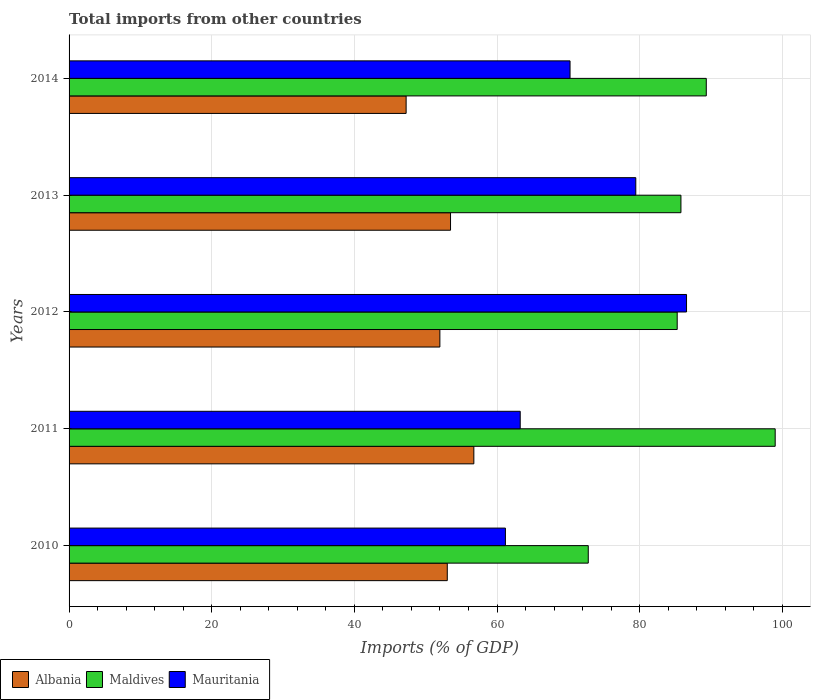Are the number of bars per tick equal to the number of legend labels?
Ensure brevity in your answer.  Yes. What is the label of the 1st group of bars from the top?
Your answer should be very brief. 2014. What is the total imports in Albania in 2012?
Your response must be concise. 51.99. Across all years, what is the maximum total imports in Mauritania?
Give a very brief answer. 86.57. Across all years, what is the minimum total imports in Albania?
Your answer should be compact. 47.25. In which year was the total imports in Albania maximum?
Your answer should be compact. 2011. In which year was the total imports in Mauritania minimum?
Your answer should be compact. 2010. What is the total total imports in Mauritania in the graph?
Your answer should be compact. 360.68. What is the difference between the total imports in Maldives in 2010 and that in 2011?
Your response must be concise. -26.21. What is the difference between the total imports in Maldives in 2014 and the total imports in Mauritania in 2012?
Offer a very short reply. 2.77. What is the average total imports in Albania per year?
Keep it short and to the point. 52.5. In the year 2012, what is the difference between the total imports in Albania and total imports in Maldives?
Provide a succinct answer. -33.27. What is the ratio of the total imports in Maldives in 2011 to that in 2013?
Your answer should be compact. 1.15. Is the total imports in Mauritania in 2010 less than that in 2014?
Your answer should be very brief. Yes. What is the difference between the highest and the second highest total imports in Mauritania?
Provide a short and direct response. 7.11. What is the difference between the highest and the lowest total imports in Albania?
Give a very brief answer. 9.49. Is the sum of the total imports in Maldives in 2010 and 2014 greater than the maximum total imports in Albania across all years?
Offer a terse response. Yes. What does the 3rd bar from the top in 2012 represents?
Keep it short and to the point. Albania. What does the 2nd bar from the bottom in 2010 represents?
Keep it short and to the point. Maldives. Does the graph contain any zero values?
Your answer should be very brief. No. Does the graph contain grids?
Provide a short and direct response. Yes. How many legend labels are there?
Your answer should be very brief. 3. What is the title of the graph?
Your answer should be compact. Total imports from other countries. Does "Egypt, Arab Rep." appear as one of the legend labels in the graph?
Offer a very short reply. No. What is the label or title of the X-axis?
Provide a succinct answer. Imports (% of GDP). What is the label or title of the Y-axis?
Offer a terse response. Years. What is the Imports (% of GDP) in Albania in 2010?
Provide a short and direct response. 53.02. What is the Imports (% of GDP) of Maldives in 2010?
Offer a very short reply. 72.79. What is the Imports (% of GDP) of Mauritania in 2010?
Provide a short and direct response. 61.18. What is the Imports (% of GDP) of Albania in 2011?
Your answer should be very brief. 56.75. What is the Imports (% of GDP) of Maldives in 2011?
Provide a short and direct response. 99. What is the Imports (% of GDP) in Mauritania in 2011?
Ensure brevity in your answer.  63.25. What is the Imports (% of GDP) of Albania in 2012?
Make the answer very short. 51.99. What is the Imports (% of GDP) in Maldives in 2012?
Your answer should be compact. 85.26. What is the Imports (% of GDP) in Mauritania in 2012?
Offer a very short reply. 86.57. What is the Imports (% of GDP) in Albania in 2013?
Your answer should be very brief. 53.48. What is the Imports (% of GDP) of Maldives in 2013?
Provide a succinct answer. 85.78. What is the Imports (% of GDP) in Mauritania in 2013?
Your response must be concise. 79.45. What is the Imports (% of GDP) in Albania in 2014?
Your answer should be compact. 47.25. What is the Imports (% of GDP) in Maldives in 2014?
Give a very brief answer. 89.34. What is the Imports (% of GDP) in Mauritania in 2014?
Keep it short and to the point. 70.24. Across all years, what is the maximum Imports (% of GDP) in Albania?
Give a very brief answer. 56.75. Across all years, what is the maximum Imports (% of GDP) of Maldives?
Provide a short and direct response. 99. Across all years, what is the maximum Imports (% of GDP) of Mauritania?
Your response must be concise. 86.57. Across all years, what is the minimum Imports (% of GDP) of Albania?
Ensure brevity in your answer.  47.25. Across all years, what is the minimum Imports (% of GDP) of Maldives?
Your response must be concise. 72.79. Across all years, what is the minimum Imports (% of GDP) of Mauritania?
Offer a very short reply. 61.18. What is the total Imports (% of GDP) of Albania in the graph?
Make the answer very short. 262.5. What is the total Imports (% of GDP) in Maldives in the graph?
Your answer should be compact. 432.17. What is the total Imports (% of GDP) of Mauritania in the graph?
Provide a succinct answer. 360.68. What is the difference between the Imports (% of GDP) in Albania in 2010 and that in 2011?
Provide a short and direct response. -3.72. What is the difference between the Imports (% of GDP) in Maldives in 2010 and that in 2011?
Make the answer very short. -26.21. What is the difference between the Imports (% of GDP) in Mauritania in 2010 and that in 2011?
Ensure brevity in your answer.  -2.08. What is the difference between the Imports (% of GDP) of Albania in 2010 and that in 2012?
Your response must be concise. 1.04. What is the difference between the Imports (% of GDP) in Maldives in 2010 and that in 2012?
Provide a succinct answer. -12.47. What is the difference between the Imports (% of GDP) of Mauritania in 2010 and that in 2012?
Keep it short and to the point. -25.39. What is the difference between the Imports (% of GDP) of Albania in 2010 and that in 2013?
Make the answer very short. -0.46. What is the difference between the Imports (% of GDP) of Maldives in 2010 and that in 2013?
Provide a short and direct response. -12.99. What is the difference between the Imports (% of GDP) of Mauritania in 2010 and that in 2013?
Give a very brief answer. -18.28. What is the difference between the Imports (% of GDP) in Albania in 2010 and that in 2014?
Offer a terse response. 5.77. What is the difference between the Imports (% of GDP) of Maldives in 2010 and that in 2014?
Your response must be concise. -16.54. What is the difference between the Imports (% of GDP) in Mauritania in 2010 and that in 2014?
Give a very brief answer. -9.06. What is the difference between the Imports (% of GDP) of Albania in 2011 and that in 2012?
Your response must be concise. 4.76. What is the difference between the Imports (% of GDP) of Maldives in 2011 and that in 2012?
Give a very brief answer. 13.74. What is the difference between the Imports (% of GDP) in Mauritania in 2011 and that in 2012?
Provide a short and direct response. -23.32. What is the difference between the Imports (% of GDP) of Albania in 2011 and that in 2013?
Your response must be concise. 3.27. What is the difference between the Imports (% of GDP) in Maldives in 2011 and that in 2013?
Offer a terse response. 13.21. What is the difference between the Imports (% of GDP) in Mauritania in 2011 and that in 2013?
Your response must be concise. -16.2. What is the difference between the Imports (% of GDP) in Albania in 2011 and that in 2014?
Offer a very short reply. 9.49. What is the difference between the Imports (% of GDP) of Maldives in 2011 and that in 2014?
Your answer should be very brief. 9.66. What is the difference between the Imports (% of GDP) of Mauritania in 2011 and that in 2014?
Your response must be concise. -6.98. What is the difference between the Imports (% of GDP) in Albania in 2012 and that in 2013?
Provide a succinct answer. -1.49. What is the difference between the Imports (% of GDP) in Maldives in 2012 and that in 2013?
Offer a very short reply. -0.52. What is the difference between the Imports (% of GDP) of Mauritania in 2012 and that in 2013?
Provide a short and direct response. 7.11. What is the difference between the Imports (% of GDP) in Albania in 2012 and that in 2014?
Your answer should be compact. 4.73. What is the difference between the Imports (% of GDP) of Maldives in 2012 and that in 2014?
Give a very brief answer. -4.08. What is the difference between the Imports (% of GDP) of Mauritania in 2012 and that in 2014?
Your answer should be compact. 16.33. What is the difference between the Imports (% of GDP) of Albania in 2013 and that in 2014?
Provide a succinct answer. 6.23. What is the difference between the Imports (% of GDP) of Maldives in 2013 and that in 2014?
Give a very brief answer. -3.55. What is the difference between the Imports (% of GDP) in Mauritania in 2013 and that in 2014?
Your response must be concise. 9.22. What is the difference between the Imports (% of GDP) in Albania in 2010 and the Imports (% of GDP) in Maldives in 2011?
Offer a terse response. -45.97. What is the difference between the Imports (% of GDP) in Albania in 2010 and the Imports (% of GDP) in Mauritania in 2011?
Keep it short and to the point. -10.23. What is the difference between the Imports (% of GDP) in Maldives in 2010 and the Imports (% of GDP) in Mauritania in 2011?
Give a very brief answer. 9.54. What is the difference between the Imports (% of GDP) in Albania in 2010 and the Imports (% of GDP) in Maldives in 2012?
Make the answer very short. -32.24. What is the difference between the Imports (% of GDP) of Albania in 2010 and the Imports (% of GDP) of Mauritania in 2012?
Ensure brevity in your answer.  -33.54. What is the difference between the Imports (% of GDP) in Maldives in 2010 and the Imports (% of GDP) in Mauritania in 2012?
Make the answer very short. -13.78. What is the difference between the Imports (% of GDP) of Albania in 2010 and the Imports (% of GDP) of Maldives in 2013?
Your answer should be very brief. -32.76. What is the difference between the Imports (% of GDP) in Albania in 2010 and the Imports (% of GDP) in Mauritania in 2013?
Your response must be concise. -26.43. What is the difference between the Imports (% of GDP) in Maldives in 2010 and the Imports (% of GDP) in Mauritania in 2013?
Provide a short and direct response. -6.66. What is the difference between the Imports (% of GDP) in Albania in 2010 and the Imports (% of GDP) in Maldives in 2014?
Give a very brief answer. -36.31. What is the difference between the Imports (% of GDP) of Albania in 2010 and the Imports (% of GDP) of Mauritania in 2014?
Your response must be concise. -17.21. What is the difference between the Imports (% of GDP) of Maldives in 2010 and the Imports (% of GDP) of Mauritania in 2014?
Give a very brief answer. 2.56. What is the difference between the Imports (% of GDP) in Albania in 2011 and the Imports (% of GDP) in Maldives in 2012?
Provide a succinct answer. -28.51. What is the difference between the Imports (% of GDP) in Albania in 2011 and the Imports (% of GDP) in Mauritania in 2012?
Ensure brevity in your answer.  -29.82. What is the difference between the Imports (% of GDP) of Maldives in 2011 and the Imports (% of GDP) of Mauritania in 2012?
Offer a terse response. 12.43. What is the difference between the Imports (% of GDP) in Albania in 2011 and the Imports (% of GDP) in Maldives in 2013?
Offer a very short reply. -29.04. What is the difference between the Imports (% of GDP) in Albania in 2011 and the Imports (% of GDP) in Mauritania in 2013?
Your response must be concise. -22.7. What is the difference between the Imports (% of GDP) of Maldives in 2011 and the Imports (% of GDP) of Mauritania in 2013?
Your response must be concise. 19.54. What is the difference between the Imports (% of GDP) of Albania in 2011 and the Imports (% of GDP) of Maldives in 2014?
Keep it short and to the point. -32.59. What is the difference between the Imports (% of GDP) of Albania in 2011 and the Imports (% of GDP) of Mauritania in 2014?
Make the answer very short. -13.49. What is the difference between the Imports (% of GDP) of Maldives in 2011 and the Imports (% of GDP) of Mauritania in 2014?
Provide a succinct answer. 28.76. What is the difference between the Imports (% of GDP) of Albania in 2012 and the Imports (% of GDP) of Maldives in 2013?
Your answer should be compact. -33.8. What is the difference between the Imports (% of GDP) of Albania in 2012 and the Imports (% of GDP) of Mauritania in 2013?
Offer a terse response. -27.47. What is the difference between the Imports (% of GDP) in Maldives in 2012 and the Imports (% of GDP) in Mauritania in 2013?
Your answer should be very brief. 5.81. What is the difference between the Imports (% of GDP) of Albania in 2012 and the Imports (% of GDP) of Maldives in 2014?
Provide a succinct answer. -37.35. What is the difference between the Imports (% of GDP) in Albania in 2012 and the Imports (% of GDP) in Mauritania in 2014?
Keep it short and to the point. -18.25. What is the difference between the Imports (% of GDP) in Maldives in 2012 and the Imports (% of GDP) in Mauritania in 2014?
Your response must be concise. 15.02. What is the difference between the Imports (% of GDP) in Albania in 2013 and the Imports (% of GDP) in Maldives in 2014?
Ensure brevity in your answer.  -35.86. What is the difference between the Imports (% of GDP) of Albania in 2013 and the Imports (% of GDP) of Mauritania in 2014?
Provide a succinct answer. -16.76. What is the difference between the Imports (% of GDP) in Maldives in 2013 and the Imports (% of GDP) in Mauritania in 2014?
Your answer should be very brief. 15.55. What is the average Imports (% of GDP) in Albania per year?
Keep it short and to the point. 52.5. What is the average Imports (% of GDP) in Maldives per year?
Provide a short and direct response. 86.43. What is the average Imports (% of GDP) in Mauritania per year?
Ensure brevity in your answer.  72.14. In the year 2010, what is the difference between the Imports (% of GDP) of Albania and Imports (% of GDP) of Maldives?
Provide a succinct answer. -19.77. In the year 2010, what is the difference between the Imports (% of GDP) of Albania and Imports (% of GDP) of Mauritania?
Your response must be concise. -8.15. In the year 2010, what is the difference between the Imports (% of GDP) of Maldives and Imports (% of GDP) of Mauritania?
Your answer should be compact. 11.62. In the year 2011, what is the difference between the Imports (% of GDP) in Albania and Imports (% of GDP) in Maldives?
Provide a short and direct response. -42.25. In the year 2011, what is the difference between the Imports (% of GDP) of Albania and Imports (% of GDP) of Mauritania?
Ensure brevity in your answer.  -6.5. In the year 2011, what is the difference between the Imports (% of GDP) of Maldives and Imports (% of GDP) of Mauritania?
Make the answer very short. 35.75. In the year 2012, what is the difference between the Imports (% of GDP) of Albania and Imports (% of GDP) of Maldives?
Provide a succinct answer. -33.27. In the year 2012, what is the difference between the Imports (% of GDP) of Albania and Imports (% of GDP) of Mauritania?
Your answer should be compact. -34.58. In the year 2012, what is the difference between the Imports (% of GDP) of Maldives and Imports (% of GDP) of Mauritania?
Offer a terse response. -1.31. In the year 2013, what is the difference between the Imports (% of GDP) of Albania and Imports (% of GDP) of Maldives?
Your answer should be compact. -32.3. In the year 2013, what is the difference between the Imports (% of GDP) in Albania and Imports (% of GDP) in Mauritania?
Ensure brevity in your answer.  -25.97. In the year 2013, what is the difference between the Imports (% of GDP) of Maldives and Imports (% of GDP) of Mauritania?
Ensure brevity in your answer.  6.33. In the year 2014, what is the difference between the Imports (% of GDP) of Albania and Imports (% of GDP) of Maldives?
Make the answer very short. -42.08. In the year 2014, what is the difference between the Imports (% of GDP) of Albania and Imports (% of GDP) of Mauritania?
Your answer should be very brief. -22.98. In the year 2014, what is the difference between the Imports (% of GDP) of Maldives and Imports (% of GDP) of Mauritania?
Your response must be concise. 19.1. What is the ratio of the Imports (% of GDP) in Albania in 2010 to that in 2011?
Offer a terse response. 0.93. What is the ratio of the Imports (% of GDP) in Maldives in 2010 to that in 2011?
Your answer should be very brief. 0.74. What is the ratio of the Imports (% of GDP) in Mauritania in 2010 to that in 2011?
Ensure brevity in your answer.  0.97. What is the ratio of the Imports (% of GDP) in Albania in 2010 to that in 2012?
Give a very brief answer. 1.02. What is the ratio of the Imports (% of GDP) in Maldives in 2010 to that in 2012?
Give a very brief answer. 0.85. What is the ratio of the Imports (% of GDP) in Mauritania in 2010 to that in 2012?
Provide a short and direct response. 0.71. What is the ratio of the Imports (% of GDP) in Maldives in 2010 to that in 2013?
Your answer should be very brief. 0.85. What is the ratio of the Imports (% of GDP) of Mauritania in 2010 to that in 2013?
Offer a terse response. 0.77. What is the ratio of the Imports (% of GDP) in Albania in 2010 to that in 2014?
Your answer should be very brief. 1.12. What is the ratio of the Imports (% of GDP) in Maldives in 2010 to that in 2014?
Your answer should be compact. 0.81. What is the ratio of the Imports (% of GDP) in Mauritania in 2010 to that in 2014?
Offer a very short reply. 0.87. What is the ratio of the Imports (% of GDP) in Albania in 2011 to that in 2012?
Offer a very short reply. 1.09. What is the ratio of the Imports (% of GDP) of Maldives in 2011 to that in 2012?
Provide a short and direct response. 1.16. What is the ratio of the Imports (% of GDP) in Mauritania in 2011 to that in 2012?
Provide a succinct answer. 0.73. What is the ratio of the Imports (% of GDP) in Albania in 2011 to that in 2013?
Make the answer very short. 1.06. What is the ratio of the Imports (% of GDP) of Maldives in 2011 to that in 2013?
Your response must be concise. 1.15. What is the ratio of the Imports (% of GDP) in Mauritania in 2011 to that in 2013?
Keep it short and to the point. 0.8. What is the ratio of the Imports (% of GDP) of Albania in 2011 to that in 2014?
Provide a short and direct response. 1.2. What is the ratio of the Imports (% of GDP) in Maldives in 2011 to that in 2014?
Offer a very short reply. 1.11. What is the ratio of the Imports (% of GDP) of Mauritania in 2011 to that in 2014?
Provide a short and direct response. 0.9. What is the ratio of the Imports (% of GDP) of Albania in 2012 to that in 2013?
Provide a short and direct response. 0.97. What is the ratio of the Imports (% of GDP) of Maldives in 2012 to that in 2013?
Ensure brevity in your answer.  0.99. What is the ratio of the Imports (% of GDP) of Mauritania in 2012 to that in 2013?
Offer a terse response. 1.09. What is the ratio of the Imports (% of GDP) in Albania in 2012 to that in 2014?
Your response must be concise. 1.1. What is the ratio of the Imports (% of GDP) of Maldives in 2012 to that in 2014?
Your answer should be compact. 0.95. What is the ratio of the Imports (% of GDP) of Mauritania in 2012 to that in 2014?
Offer a very short reply. 1.23. What is the ratio of the Imports (% of GDP) in Albania in 2013 to that in 2014?
Offer a terse response. 1.13. What is the ratio of the Imports (% of GDP) of Maldives in 2013 to that in 2014?
Provide a succinct answer. 0.96. What is the ratio of the Imports (% of GDP) in Mauritania in 2013 to that in 2014?
Ensure brevity in your answer.  1.13. What is the difference between the highest and the second highest Imports (% of GDP) of Albania?
Your response must be concise. 3.27. What is the difference between the highest and the second highest Imports (% of GDP) of Maldives?
Your answer should be very brief. 9.66. What is the difference between the highest and the second highest Imports (% of GDP) of Mauritania?
Make the answer very short. 7.11. What is the difference between the highest and the lowest Imports (% of GDP) in Albania?
Provide a short and direct response. 9.49. What is the difference between the highest and the lowest Imports (% of GDP) of Maldives?
Your response must be concise. 26.21. What is the difference between the highest and the lowest Imports (% of GDP) in Mauritania?
Ensure brevity in your answer.  25.39. 